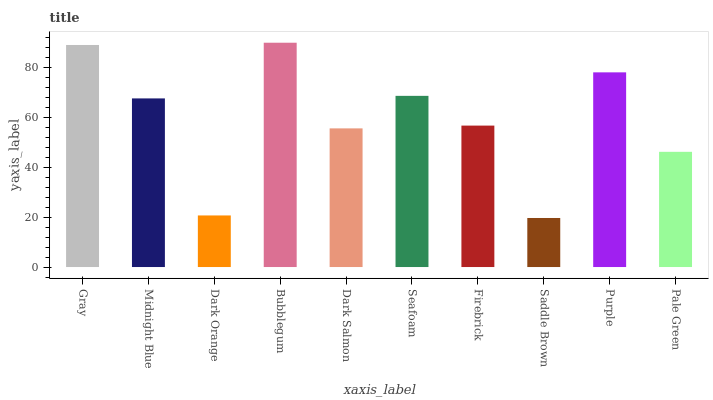Is Saddle Brown the minimum?
Answer yes or no. Yes. Is Bubblegum the maximum?
Answer yes or no. Yes. Is Midnight Blue the minimum?
Answer yes or no. No. Is Midnight Blue the maximum?
Answer yes or no. No. Is Gray greater than Midnight Blue?
Answer yes or no. Yes. Is Midnight Blue less than Gray?
Answer yes or no. Yes. Is Midnight Blue greater than Gray?
Answer yes or no. No. Is Gray less than Midnight Blue?
Answer yes or no. No. Is Midnight Blue the high median?
Answer yes or no. Yes. Is Firebrick the low median?
Answer yes or no. Yes. Is Dark Salmon the high median?
Answer yes or no. No. Is Bubblegum the low median?
Answer yes or no. No. 